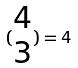<formula> <loc_0><loc_0><loc_500><loc_500>( \begin{matrix} 4 \\ 3 \end{matrix} ) = 4</formula> 